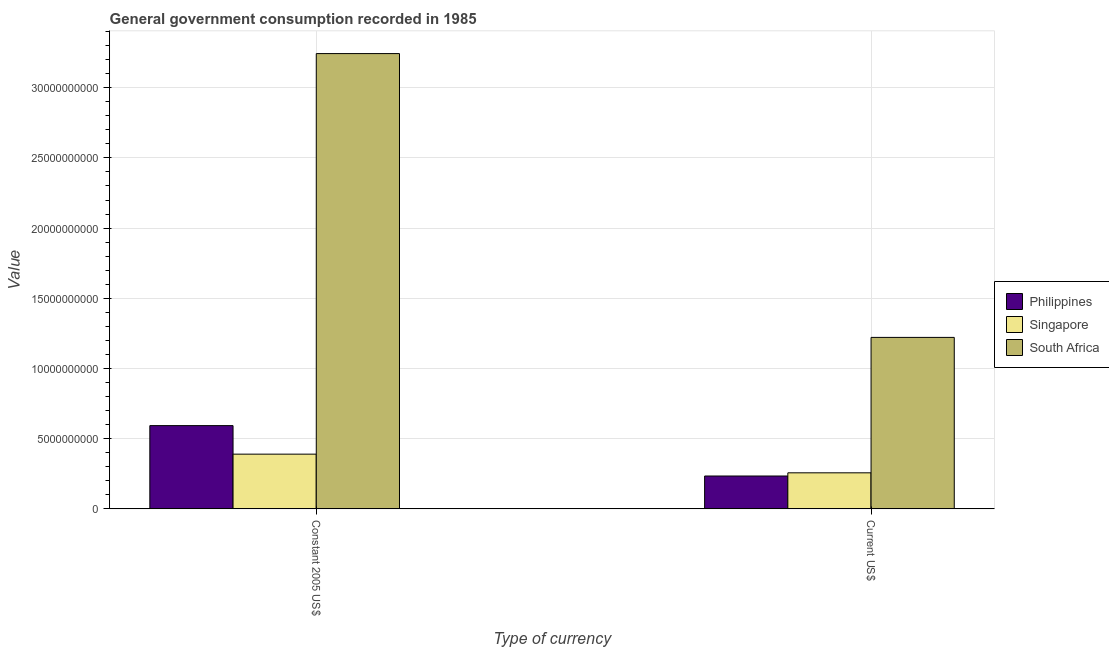How many different coloured bars are there?
Keep it short and to the point. 3. How many groups of bars are there?
Your response must be concise. 2. Are the number of bars on each tick of the X-axis equal?
Ensure brevity in your answer.  Yes. How many bars are there on the 1st tick from the left?
Give a very brief answer. 3. What is the label of the 1st group of bars from the left?
Keep it short and to the point. Constant 2005 US$. What is the value consumed in current us$ in South Africa?
Provide a short and direct response. 1.22e+1. Across all countries, what is the maximum value consumed in constant 2005 us$?
Provide a succinct answer. 3.24e+1. Across all countries, what is the minimum value consumed in constant 2005 us$?
Make the answer very short. 3.90e+09. In which country was the value consumed in constant 2005 us$ maximum?
Provide a succinct answer. South Africa. In which country was the value consumed in constant 2005 us$ minimum?
Your response must be concise. Singapore. What is the total value consumed in current us$ in the graph?
Provide a succinct answer. 1.71e+1. What is the difference between the value consumed in current us$ in Philippines and that in Singapore?
Keep it short and to the point. -2.27e+08. What is the difference between the value consumed in constant 2005 us$ in Philippines and the value consumed in current us$ in South Africa?
Ensure brevity in your answer.  -6.28e+09. What is the average value consumed in current us$ per country?
Provide a succinct answer. 5.71e+09. What is the difference between the value consumed in constant 2005 us$ and value consumed in current us$ in Philippines?
Ensure brevity in your answer.  3.59e+09. In how many countries, is the value consumed in current us$ greater than 14000000000 ?
Ensure brevity in your answer.  0. What is the ratio of the value consumed in current us$ in Singapore to that in Philippines?
Provide a succinct answer. 1.1. In how many countries, is the value consumed in current us$ greater than the average value consumed in current us$ taken over all countries?
Give a very brief answer. 1. What does the 1st bar from the left in Constant 2005 US$ represents?
Give a very brief answer. Philippines. What does the 2nd bar from the right in Current US$ represents?
Provide a short and direct response. Singapore. Are the values on the major ticks of Y-axis written in scientific E-notation?
Your answer should be very brief. No. Does the graph contain any zero values?
Provide a short and direct response. No. Does the graph contain grids?
Offer a terse response. Yes. How many legend labels are there?
Your answer should be very brief. 3. How are the legend labels stacked?
Provide a succinct answer. Vertical. What is the title of the graph?
Make the answer very short. General government consumption recorded in 1985. What is the label or title of the X-axis?
Make the answer very short. Type of currency. What is the label or title of the Y-axis?
Make the answer very short. Value. What is the Value in Philippines in Constant 2005 US$?
Provide a succinct answer. 5.93e+09. What is the Value of Singapore in Constant 2005 US$?
Your answer should be very brief. 3.90e+09. What is the Value of South Africa in Constant 2005 US$?
Offer a very short reply. 3.24e+1. What is the Value in Philippines in Current US$?
Your answer should be very brief. 2.34e+09. What is the Value in Singapore in Current US$?
Offer a very short reply. 2.57e+09. What is the Value in South Africa in Current US$?
Provide a succinct answer. 1.22e+1. Across all Type of currency, what is the maximum Value of Philippines?
Provide a succinct answer. 5.93e+09. Across all Type of currency, what is the maximum Value in Singapore?
Make the answer very short. 3.90e+09. Across all Type of currency, what is the maximum Value in South Africa?
Make the answer very short. 3.24e+1. Across all Type of currency, what is the minimum Value of Philippines?
Provide a succinct answer. 2.34e+09. Across all Type of currency, what is the minimum Value of Singapore?
Offer a very short reply. 2.57e+09. Across all Type of currency, what is the minimum Value in South Africa?
Your answer should be compact. 1.22e+1. What is the total Value in Philippines in the graph?
Give a very brief answer. 8.27e+09. What is the total Value in Singapore in the graph?
Give a very brief answer. 6.46e+09. What is the total Value in South Africa in the graph?
Your response must be concise. 4.46e+1. What is the difference between the Value of Philippines in Constant 2005 US$ and that in Current US$?
Provide a short and direct response. 3.59e+09. What is the difference between the Value in Singapore in Constant 2005 US$ and that in Current US$?
Provide a succinct answer. 1.33e+09. What is the difference between the Value of South Africa in Constant 2005 US$ and that in Current US$?
Your answer should be compact. 2.02e+1. What is the difference between the Value of Philippines in Constant 2005 US$ and the Value of Singapore in Current US$?
Make the answer very short. 3.36e+09. What is the difference between the Value in Philippines in Constant 2005 US$ and the Value in South Africa in Current US$?
Ensure brevity in your answer.  -6.28e+09. What is the difference between the Value of Singapore in Constant 2005 US$ and the Value of South Africa in Current US$?
Your response must be concise. -8.32e+09. What is the average Value of Philippines per Type of currency?
Your response must be concise. 4.13e+09. What is the average Value in Singapore per Type of currency?
Your answer should be compact. 3.23e+09. What is the average Value of South Africa per Type of currency?
Offer a very short reply. 2.23e+1. What is the difference between the Value in Philippines and Value in Singapore in Constant 2005 US$?
Offer a very short reply. 2.03e+09. What is the difference between the Value of Philippines and Value of South Africa in Constant 2005 US$?
Make the answer very short. -2.65e+1. What is the difference between the Value in Singapore and Value in South Africa in Constant 2005 US$?
Your answer should be very brief. -2.85e+1. What is the difference between the Value in Philippines and Value in Singapore in Current US$?
Provide a succinct answer. -2.27e+08. What is the difference between the Value in Philippines and Value in South Africa in Current US$?
Offer a very short reply. -9.87e+09. What is the difference between the Value of Singapore and Value of South Africa in Current US$?
Your answer should be compact. -9.65e+09. What is the ratio of the Value in Philippines in Constant 2005 US$ to that in Current US$?
Your answer should be very brief. 2.54. What is the ratio of the Value in Singapore in Constant 2005 US$ to that in Current US$?
Your answer should be very brief. 1.52. What is the ratio of the Value of South Africa in Constant 2005 US$ to that in Current US$?
Provide a short and direct response. 2.66. What is the difference between the highest and the second highest Value in Philippines?
Offer a terse response. 3.59e+09. What is the difference between the highest and the second highest Value in Singapore?
Keep it short and to the point. 1.33e+09. What is the difference between the highest and the second highest Value in South Africa?
Provide a succinct answer. 2.02e+1. What is the difference between the highest and the lowest Value of Philippines?
Give a very brief answer. 3.59e+09. What is the difference between the highest and the lowest Value of Singapore?
Your response must be concise. 1.33e+09. What is the difference between the highest and the lowest Value in South Africa?
Offer a terse response. 2.02e+1. 